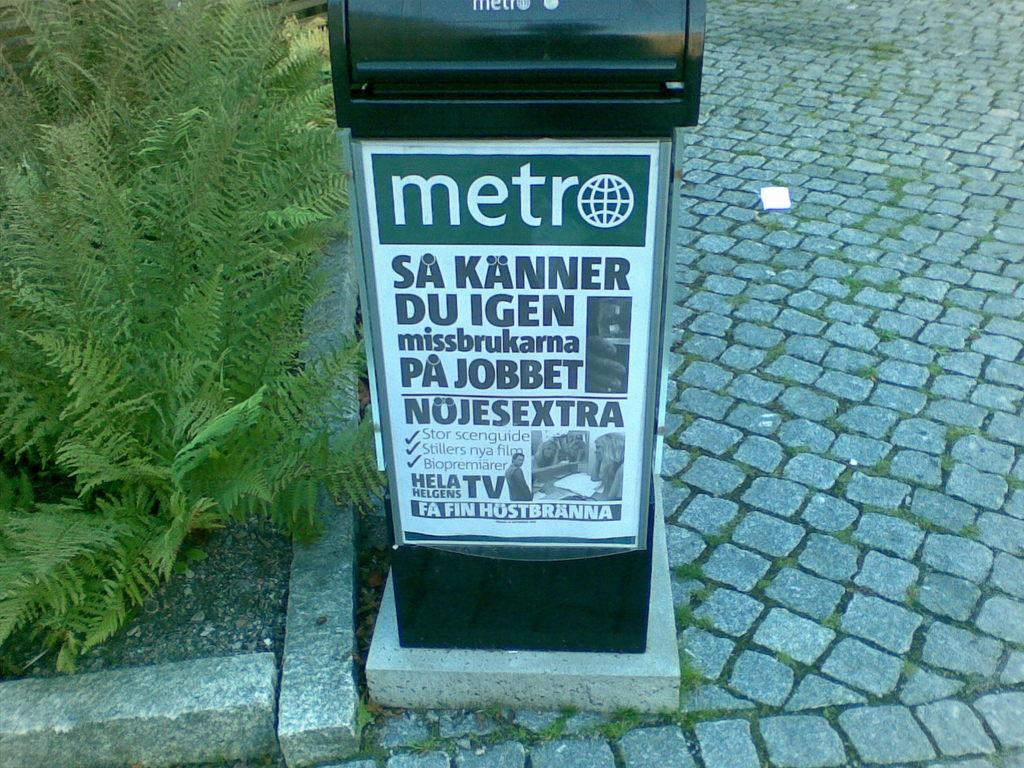What is the name of this paper?
Ensure brevity in your answer.  Metro. 